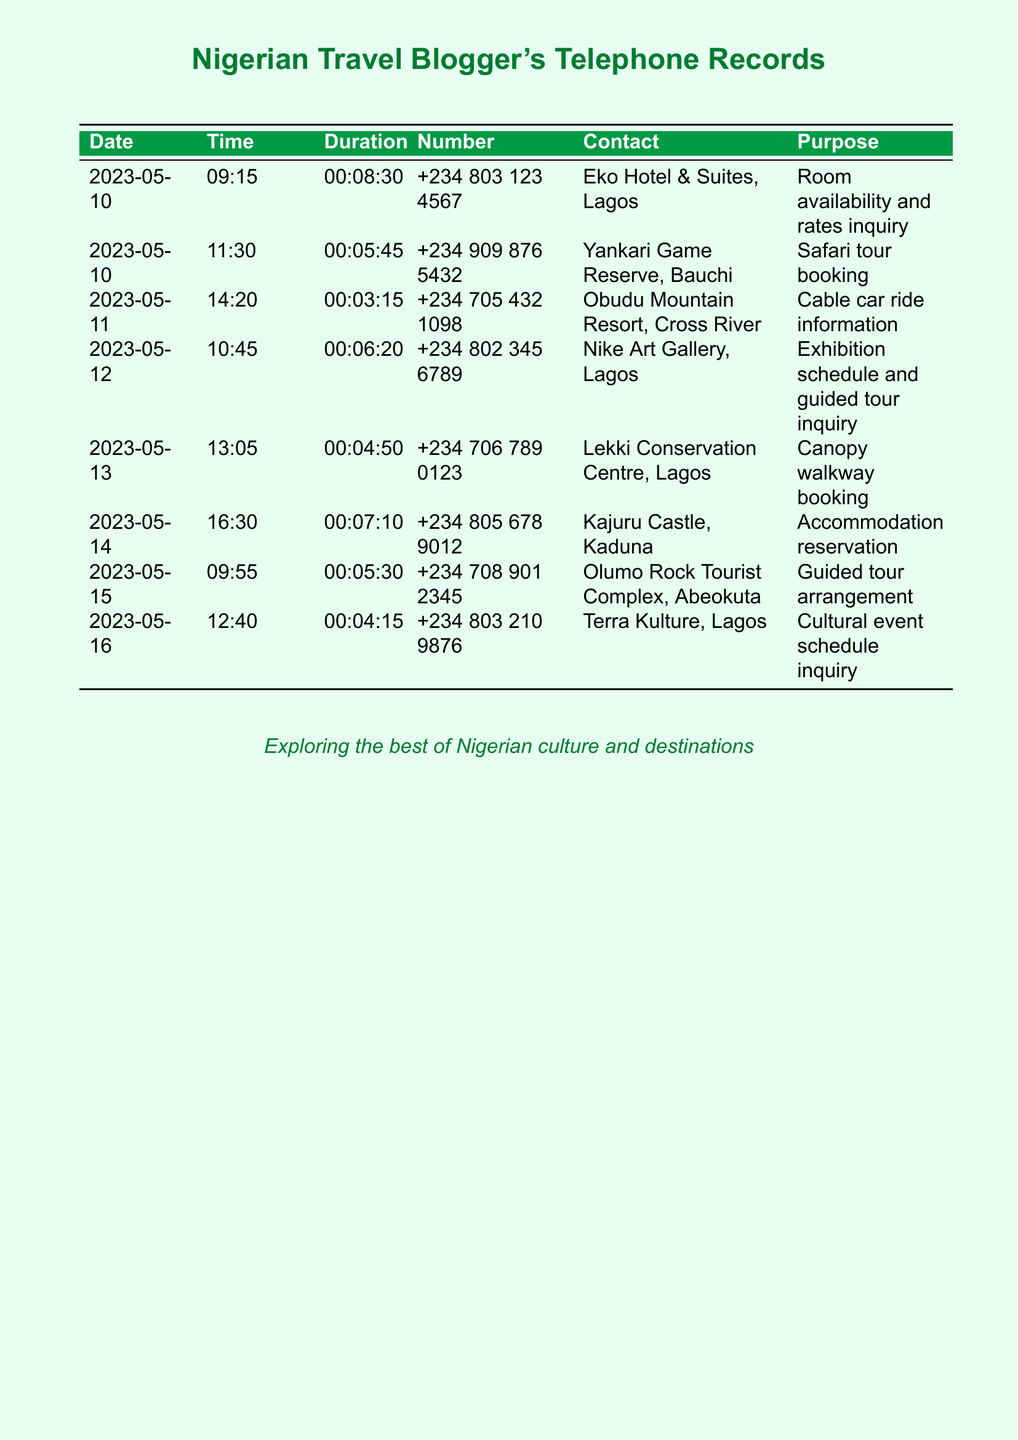What was the first call made on the 10th of May? The first call was made to Eko Hotel & Suites, Lagos, regarding room availability and rates.
Answer: Eko Hotel & Suites, Lagos What time was the call made to Nike Art Gallery? The call to Nike Art Gallery was made at 10:45 on the 12th of May.
Answer: 10:45 How long was the longest call in the records? The longest call duration is 8 minutes and 30 seconds made to Eko Hotel & Suites.
Answer: 00:08:30 Which location had a safari tour booking inquiry? The safari tour booking inquiry was made to Yankari Game Reserve, Bauchi.
Answer: Yankari Game Reserve, Bauchi What is the purpose of the call made to Lekki Conservation Centre? The purpose was for canopy walkway booking.
Answer: Canopy walkway booking How many different businesses were contacted in total? There were a total of 8 different businesses contacted based on the records provided.
Answer: 8 What date was the call regarding the accommodation reservation made? The accommodation reservation call was made on the 14th of May.
Answer: 2023-05-14 Which city is the Nike Art Gallery located in? Nike Art Gallery is located in Lagos.
Answer: Lagos What time was the guided tour arrangement call made? The guided tour arrangement call was made at 09:55 on the 15th of May.
Answer: 09:55 